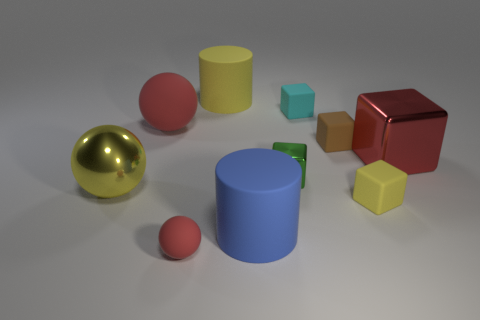What number of large objects are either cyan metallic balls or blue matte objects?
Offer a very short reply. 1. Are there any other yellow objects that have the same shape as the big yellow metallic object?
Give a very brief answer. No. Does the tiny brown thing have the same shape as the blue thing?
Your answer should be very brief. No. What is the color of the cylinder that is in front of the large yellow object that is behind the small cyan block?
Keep it short and to the point. Blue. What color is the rubber ball that is the same size as the brown rubber thing?
Provide a short and direct response. Red. What number of metallic things are tiny blue cylinders or red cubes?
Your answer should be very brief. 1. What number of yellow things are to the right of the rubber ball in front of the large blue rubber cylinder?
Keep it short and to the point. 2. What size is the metal object that is the same color as the big rubber sphere?
Provide a short and direct response. Large. How many objects are either brown things or large rubber things in front of the large block?
Provide a succinct answer. 2. Is there a tiny brown cylinder that has the same material as the large red sphere?
Keep it short and to the point. No. 